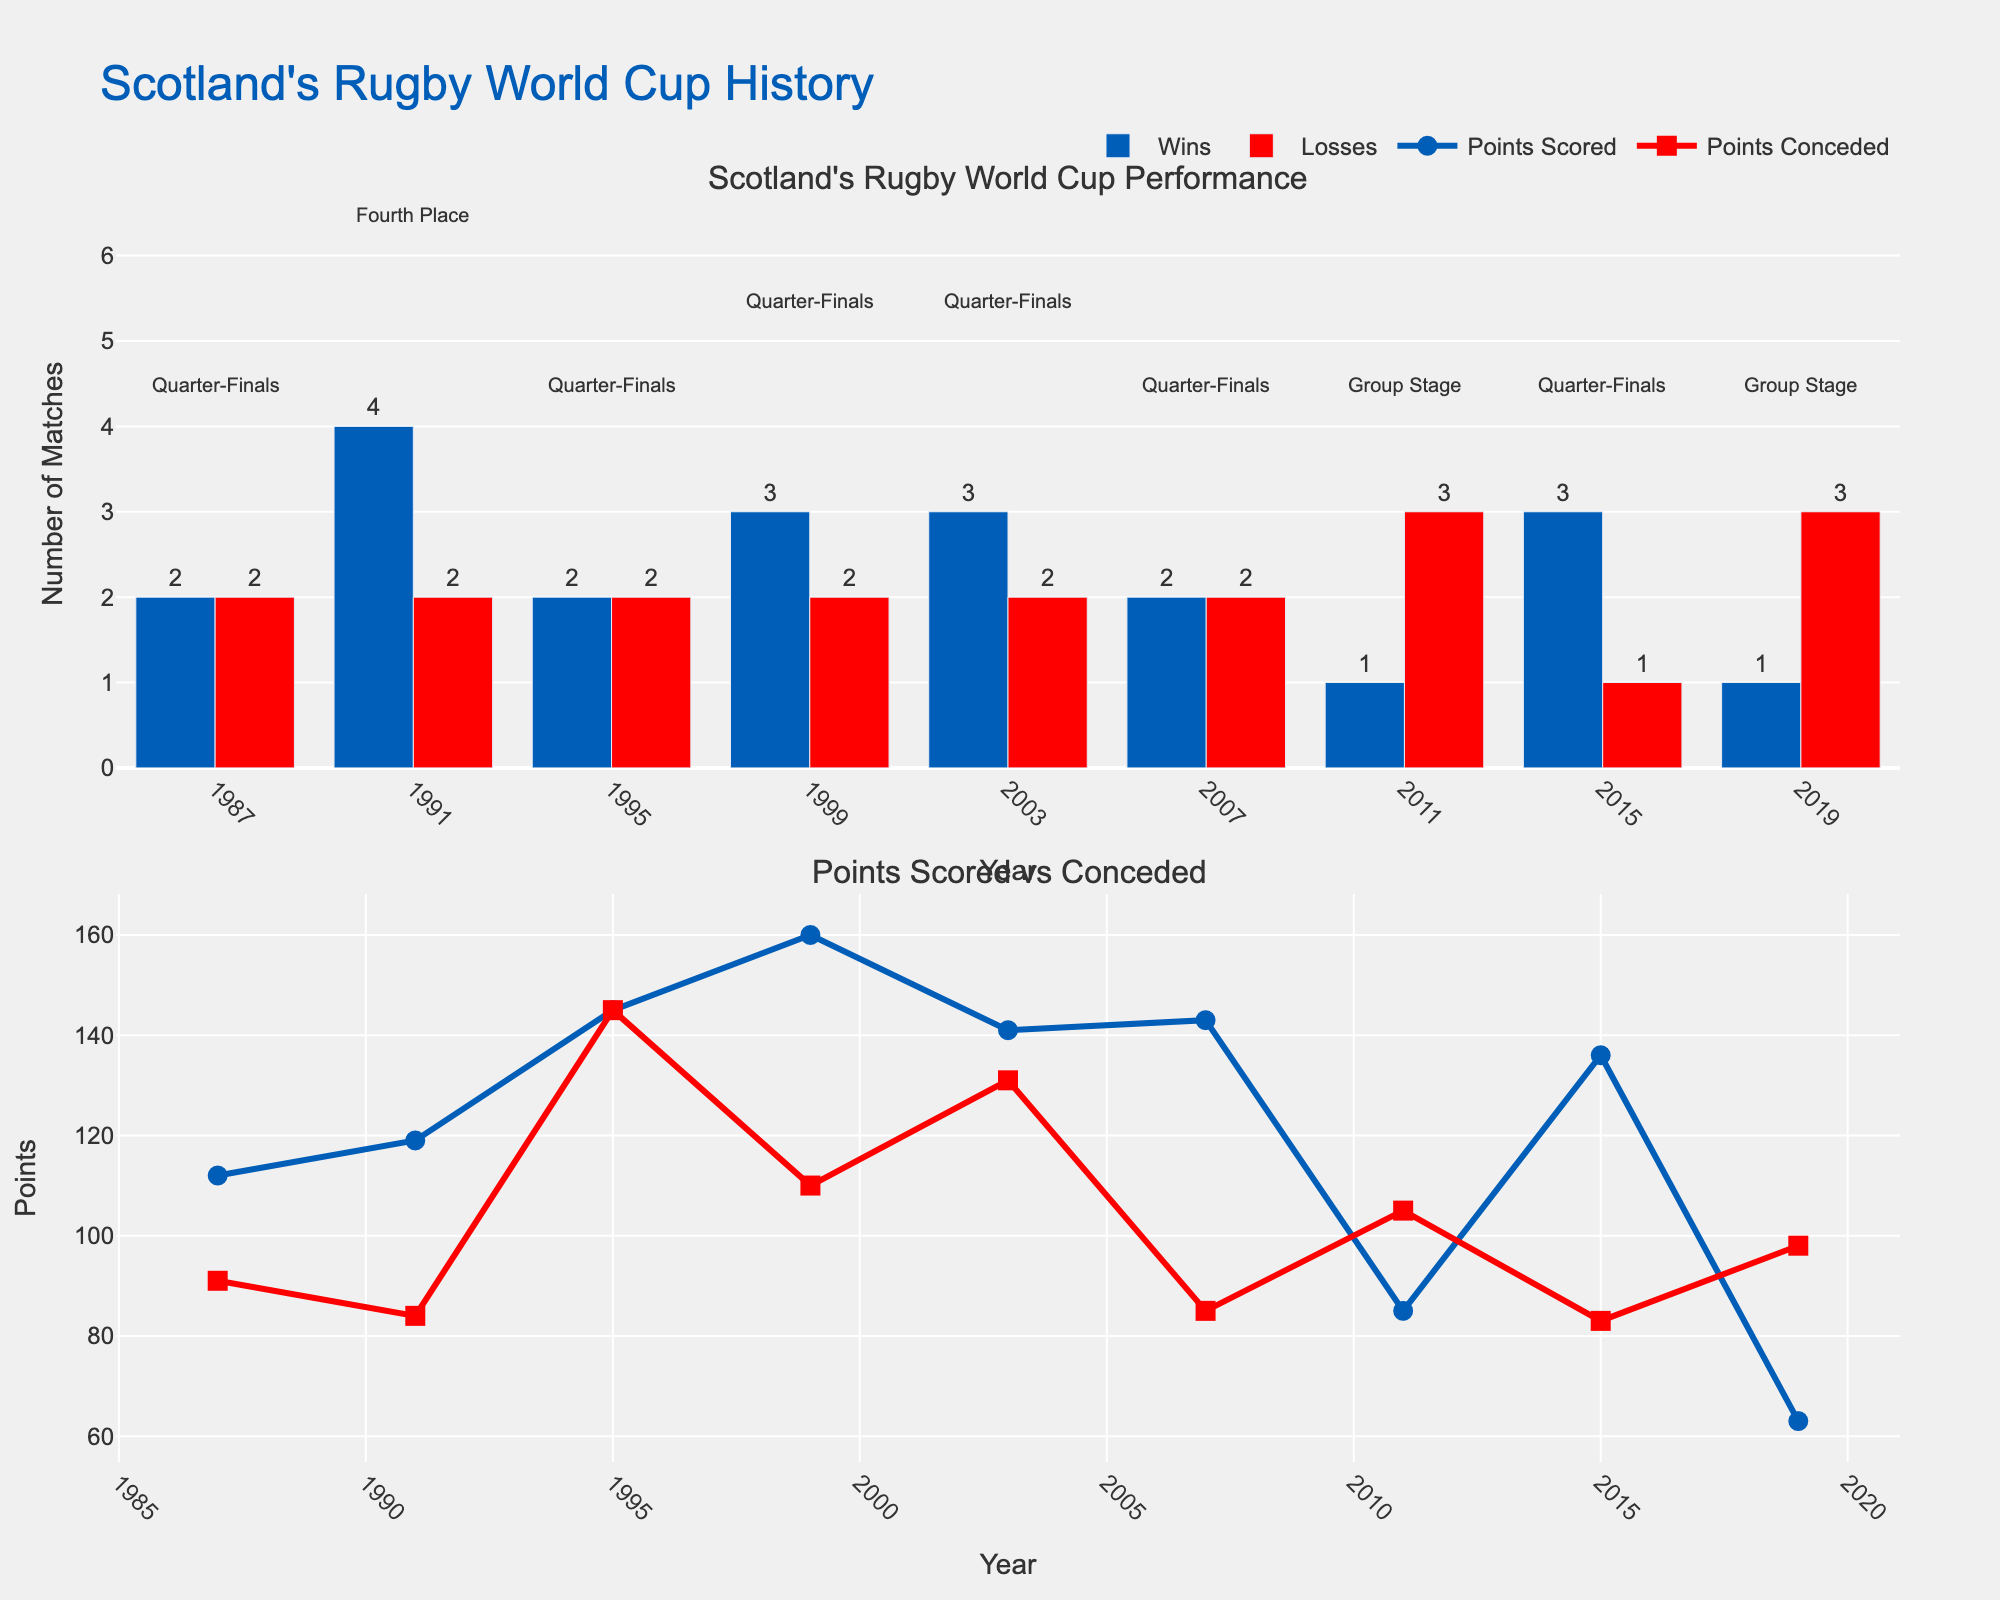Which year did Scotland score the highest number of points in the World Cup? By looking at the scatter plot in the second subplot, the highest point in the "Points Scored" line occurs in 1999.
Answer: 1999 How many wins and losses did Scotland have in the 2015 World Cup? By referring to the bar chart in the first subplot, in 2015, the blue bar (Wins) shows 3 and the red bar (Losses) shows 1.
Answer: 3 Wins, 1 Loss Which World Cup year had the greatest difference between points scored and points conceded for Scotland, and what was that difference? In the second subplot, the year 1999 has 160 points scored and 110 points conceded. The difference is 160 - 110 = 50, which is the greatest among all years.
Answer: 1999, 50 points In how many World Cups did Scotland not reach the Quarter-Finals? According to the annotations in the first subplot, Scotland did not reach the Quarter-Finals in 2011 and 2019. This makes it 2 World Cups.
Answer: 2 What is the combined total number of points Scotland scored in the World Cups where they reached the Quarter-Finals? Scotland reached the Quarter-Finals in 1987, 1995, 1999, 2003, and 2007. Summing the points scored in these years: 112 + 145 + 160 + 141 + 143 = 701.
Answer: 701 Compare the total points scored and conceded by Scotland in the 2003 World Cup. Which was higher and by how much? In 2003, Scotland scored 141 points and conceded 131 points. The difference is 141 - 131 = 10 points in favor of points scored.
Answer: Points Scored, 10 points During which years did Scotland reach the Quarter-Finals according to the chart, and how many wins and losses did they have in total across these years? From the first subplot, the years Scotland reached the Quarter-Finals are 1987, 1995, 1999, 2003, 2007, and 2015. Adding up their wins (2+2+3+3+2+3) and losses (2+2+2+2+2+1) gives 15 wins and 11 losses.
Answer: 1987, 1995, 1999, 2003, 2007, 2015; 15 Wins, 11 Losses Which World Cup year had the least points conceded by Scotland and what was the value? By looking at the scatter plot in the second subplot, the lowest point in the "Points Conceded" line occurs in 1987 with 91 points conceded.
Answer: 1987, 91 points 